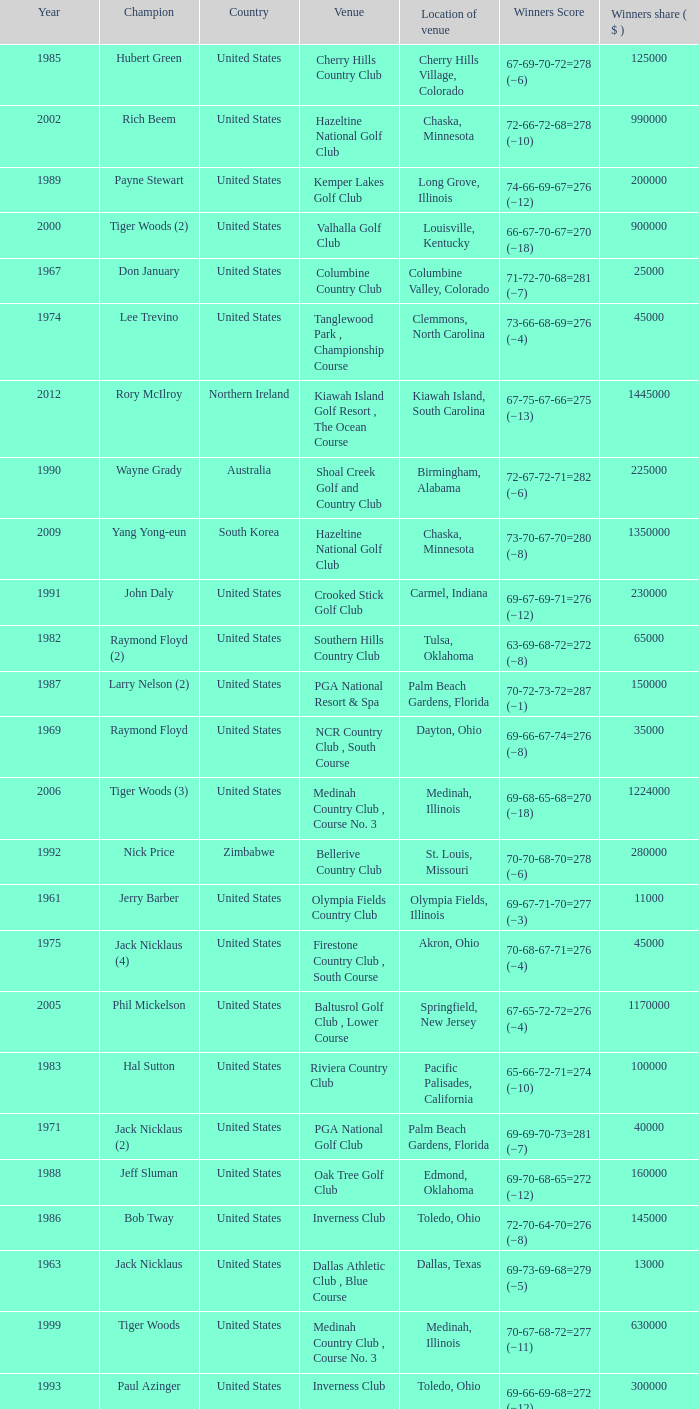Where is the Bellerive Country Club venue located? St. Louis, Missouri. 